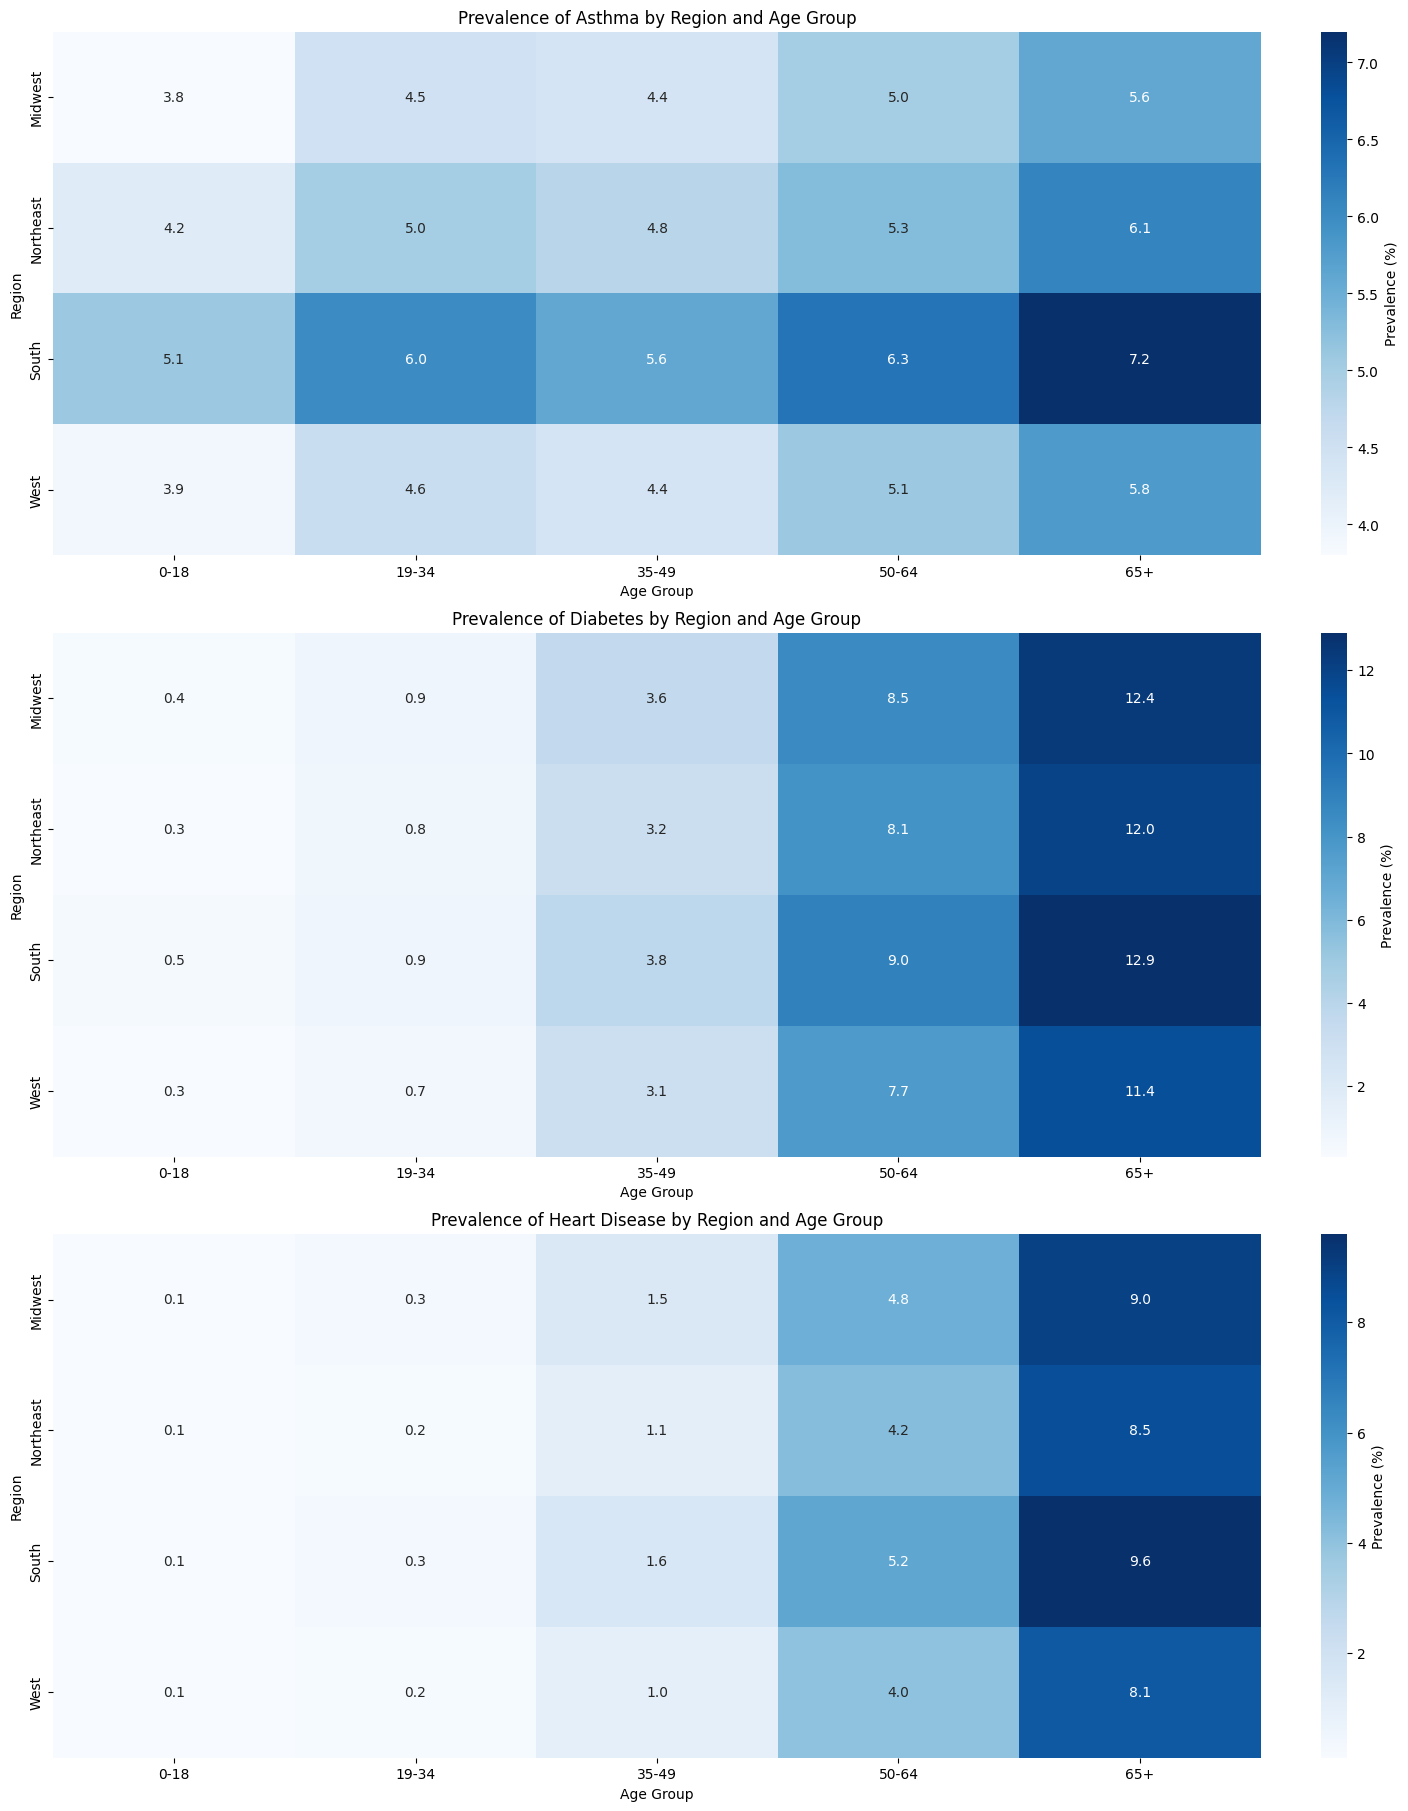What region has the highest prevalence of asthma in the 50-64 age group? The heatmap for asthma can be examined for the 50-64 age group. The South region has the highest value, which is 6.3%.
Answer: South Which age group in the Midwest has the lowest prevalence of diabetes? By looking at the diabetes heatmap for the Midwest, the 0-18 age group has the lowest prevalence, which is 0.4%.
Answer: 0-18 Compare the prevalence of heart disease between the Northeast and the West in the 65+ age group. Which region has a higher prevalence and by how much? In the heart disease heatmap, the prevalence in the Northeast for the 65+ age group is 8.5%, and in the West, it is 8.1%. The Northeast has a higher prevalence by 0.4%.
Answer: Northeast, 0.4% What is the average prevalence of asthma for the 0-18 age group across all regions? Adding the prevalence of asthma for the 0-18 age group across all regions: (4.2 + 3.8 + 5.1 + 3.9) = 17. Adding 3.8 gives an average of 4.25.
Answer: 4.25% In which age group and region does the lowest prevalence of heart disease occur? The heart disease heatmap shows the lowest prevalence value for the 0-18 age group in all regions, which is 0.1%, in the Northeast, Midwest, South, and West.
Answer: 0-18, all regions Which disease has the highest prevalence in the 65+ age group in the South region? By comparing all heatmaps for the South region in the 65+ age group, diabetes has the highest prevalence, which is 12.9%.
Answer: Diabetes Contrast the diabetes prevalence in the 19-34 age group between the Northeast and the Midwest regions. Which is higher and by how much? From the diabetes heatmap, the prevalence in the Northeast for the 19-34 age group is 0.8%, and in the Midwest, it is 0.9%. The Midwest is higher by 0.1%.
Answer: Midwest, 0.1% What is the difference between the highest and lowest prevalence of asthma across all age groups and regions? By examining the asthma heatmap, the highest prevalence is 7.2% (South, 65+) and the lowest is 3.8% (Midwest, 0-18). The difference is 7.2 - 3.8 = 3.4%.
Answer: 3.4% Which age group in the West region has the highest prevalence of heart disease? In the heart disease heatmap, the prevalence in the West region is highest for the 65+ age group, with a value of 8.1%.
Answer: 65+ 